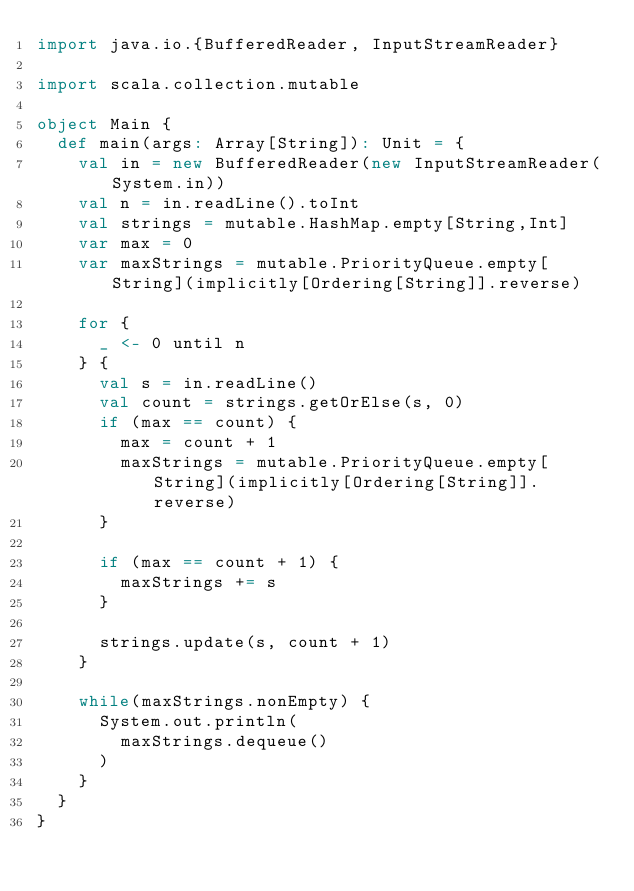<code> <loc_0><loc_0><loc_500><loc_500><_Scala_>import java.io.{BufferedReader, InputStreamReader}

import scala.collection.mutable

object Main {
  def main(args: Array[String]): Unit = {
    val in = new BufferedReader(new InputStreamReader(System.in))
    val n = in.readLine().toInt
    val strings = mutable.HashMap.empty[String,Int]
    var max = 0
    var maxStrings = mutable.PriorityQueue.empty[String](implicitly[Ordering[String]].reverse)

    for {
      _ <- 0 until n
    } {
      val s = in.readLine()
      val count = strings.getOrElse(s, 0)
      if (max == count) {
        max = count + 1
        maxStrings = mutable.PriorityQueue.empty[String](implicitly[Ordering[String]].reverse)
      }

      if (max == count + 1) {
        maxStrings += s
      }

      strings.update(s, count + 1)
    }

    while(maxStrings.nonEmpty) {
      System.out.println(
        maxStrings.dequeue()
      )
    }
  }
}
</code> 